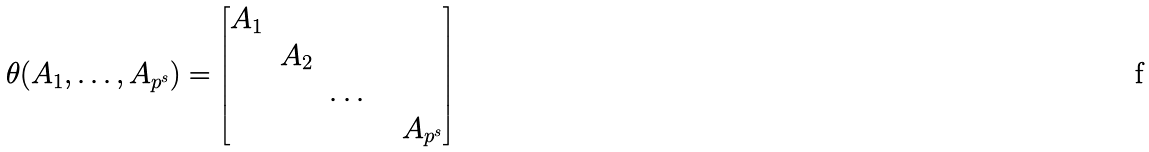<formula> <loc_0><loc_0><loc_500><loc_500>\theta ( A _ { 1 } , \dots , A _ { p ^ { s } } ) = \begin{bmatrix} A _ { 1 } & & & & \\ & A _ { 2 } & & & \\ & & \dots & & \\ & & & & A _ { p ^ { s } } \end{bmatrix}</formula> 